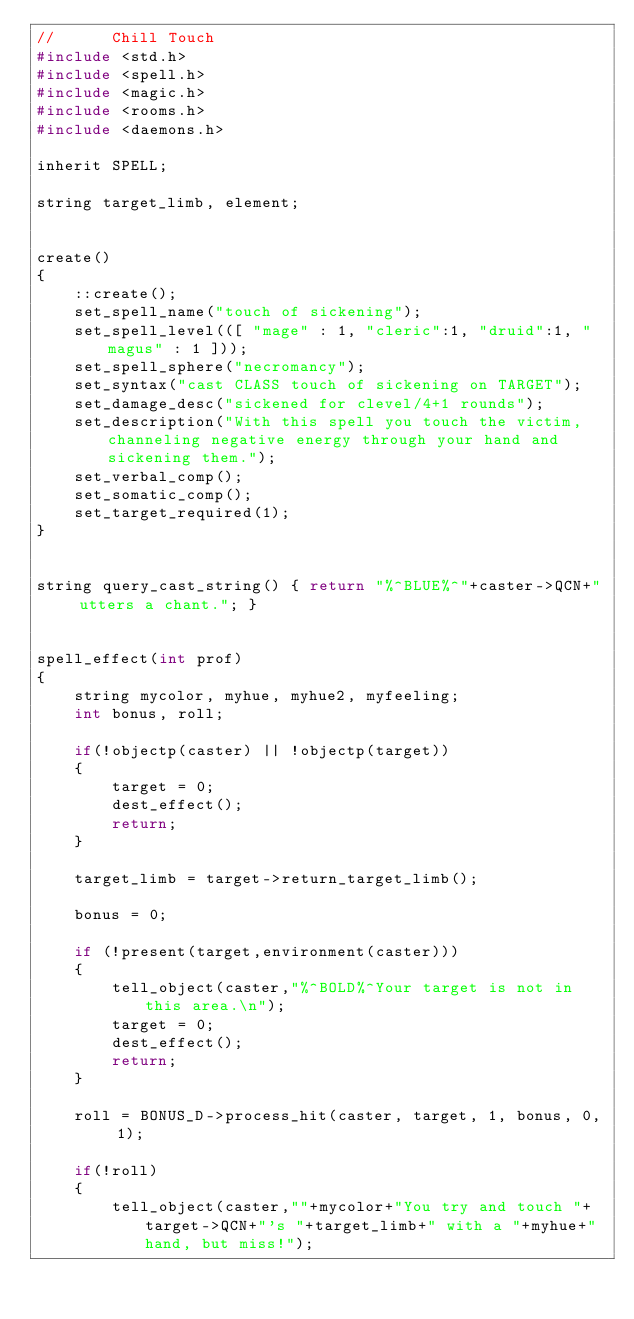<code> <loc_0><loc_0><loc_500><loc_500><_C_>//      Chill Touch
#include <std.h>
#include <spell.h>
#include <magic.h>
#include <rooms.h>
#include <daemons.h>

inherit SPELL;

string target_limb, element;


create()
{
    ::create();
    set_spell_name("touch of sickening");
    set_spell_level(([ "mage" : 1, "cleric":1, "druid":1, "magus" : 1 ]));
    set_spell_sphere("necromancy");
    set_syntax("cast CLASS touch of sickening on TARGET");
    set_damage_desc("sickened for clevel/4+1 rounds");
    set_description("With this spell you touch the victim, channeling negative energy through your hand and sickening them.");
    set_verbal_comp();
    set_somatic_comp();
    set_target_required(1);
}


string query_cast_string() { return "%^BLUE%^"+caster->QCN+" utters a chant."; }


spell_effect(int prof)
{
    string mycolor, myhue, myhue2, myfeeling;
    int bonus, roll;

    if(!objectp(caster) || !objectp(target))
    {
        target = 0;
        dest_effect();
        return;
    }

    target_limb = target->return_target_limb();

    bonus = 0;

    if (!present(target,environment(caster)))
    {
        tell_object(caster,"%^BOLD%^Your target is not in this area.\n");
        target = 0;
        dest_effect();
        return;
    }

    roll = BONUS_D->process_hit(caster, target, 1, bonus, 0, 1);

    if(!roll)
    {
        tell_object(caster,""+mycolor+"You try and touch "+target->QCN+"'s "+target_limb+" with a "+myhue+" hand, but miss!");</code> 